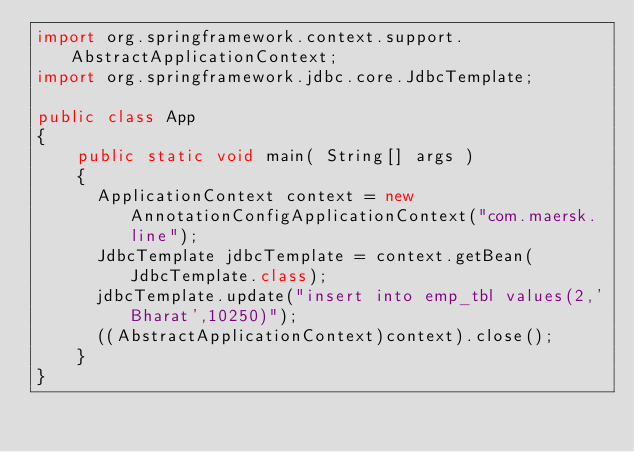Convert code to text. <code><loc_0><loc_0><loc_500><loc_500><_Java_>import org.springframework.context.support.AbstractApplicationContext;
import org.springframework.jdbc.core.JdbcTemplate;

public class App 
{
    public static void main( String[] args )
    {
      ApplicationContext context = new AnnotationConfigApplicationContext("com.maersk.line");
      JdbcTemplate jdbcTemplate = context.getBean(JdbcTemplate.class);
      jdbcTemplate.update("insert into emp_tbl values(2,'Bharat',10250)");
      ((AbstractApplicationContext)context).close();
    }
}
</code> 